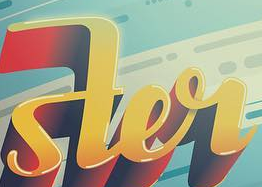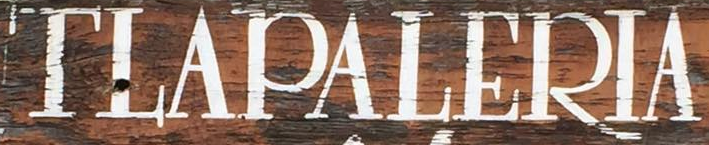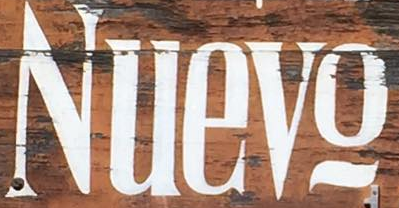What words can you see in these images in sequence, separated by a semicolon? ster; TLAPALERIA; Nuevo 